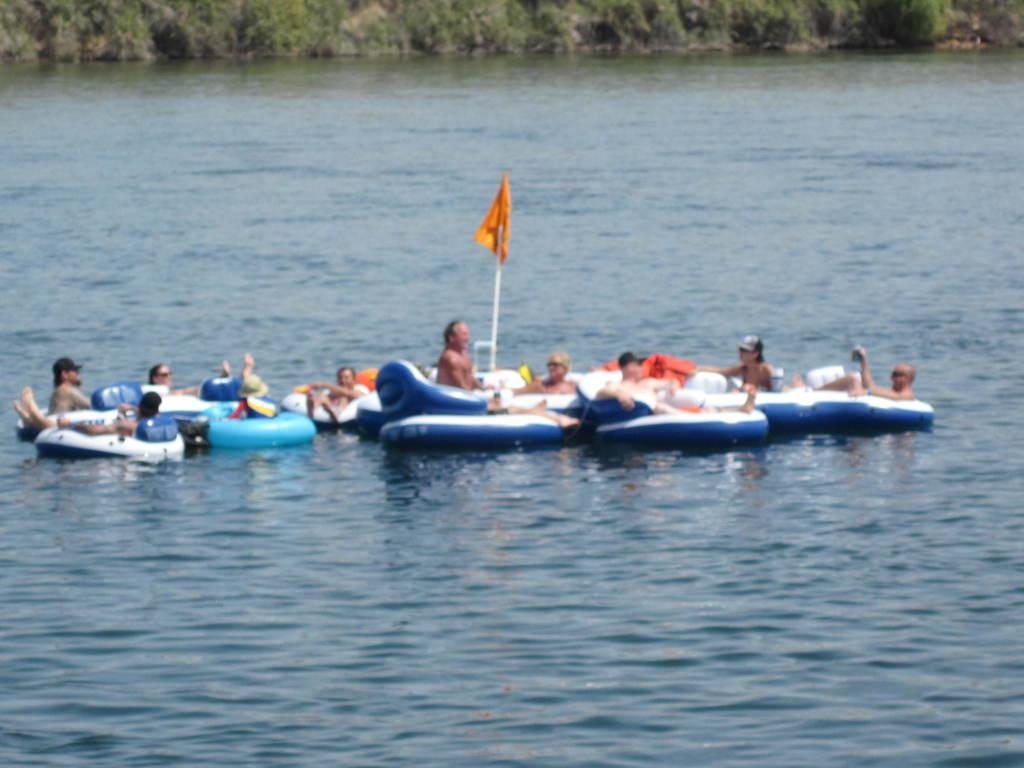What is located in the middle of the image? There is water in the middle of the image. What are the people in the image doing? The people are sitting on boats above the water. What type of vegetation can be seen at the top of the image? There are trees visible at the top of the image. What type of leather roll can be seen in the image? There is no leather roll present in the image. Is there a scarf visible on any of the people in the image? The image does not show any scarves on the people. 